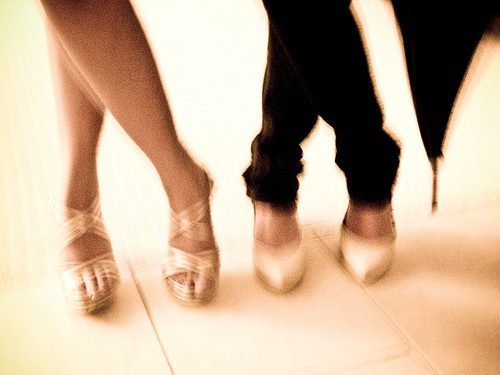Describe the objects in this image and their specific colors. I can see people in khaki, tan, brown, red, and ivory tones, people in khaki, black, tan, and salmon tones, and umbrella in khaki, black, brown, tan, and maroon tones in this image. 